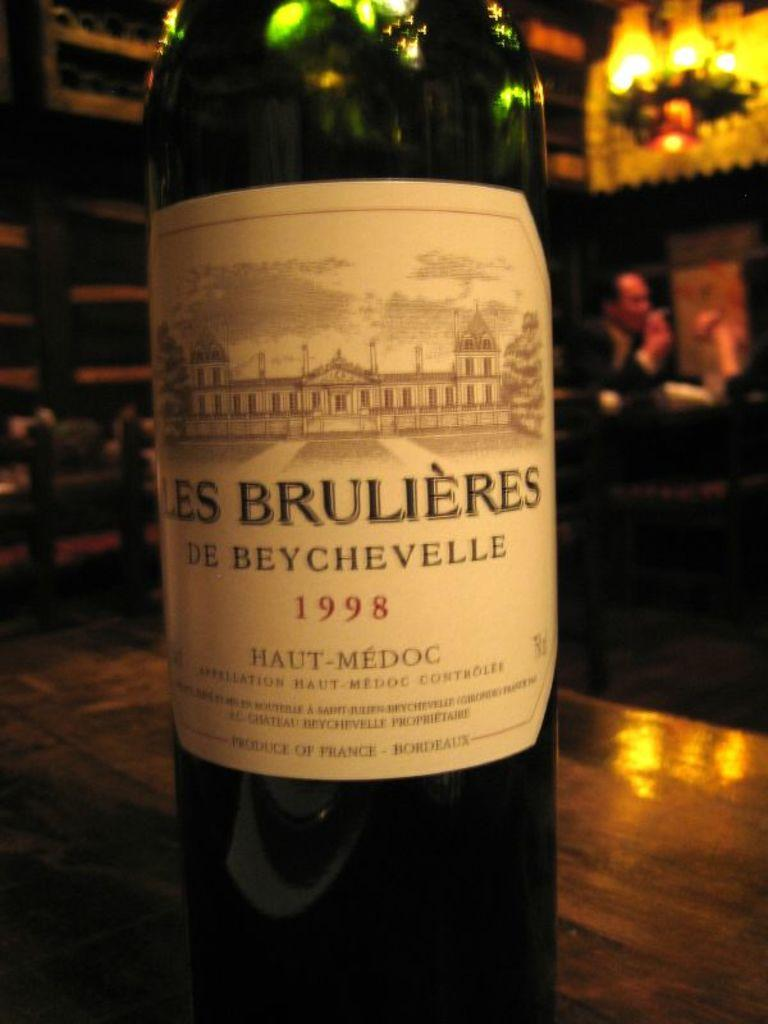<image>
Write a terse but informative summary of the picture. A bottle of Les Brulieres de Beychevelle from 1998. 